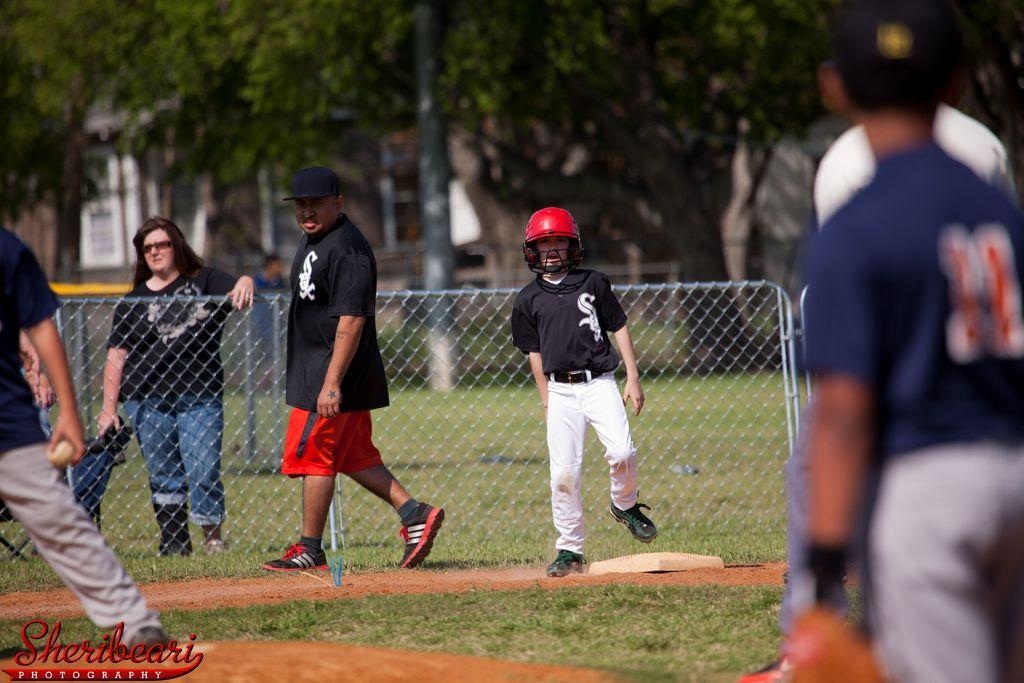How many people are in the image? There is a group of people in the image, but the exact number is not specified. What are some of the people in the image doing? Some people are standing, and some are walking. What can be seen in the background of the image? There is a fence, trees, a building with windows, and a pole in the image. What type of cow can be seen grazing near the fence in the image? There is no cow present in the image; it features a group of people and various background elements. What kind of treatment is being administered to the people in the image? There is no indication of any treatment being administered to the people in the image; they are simply standing or walking. 